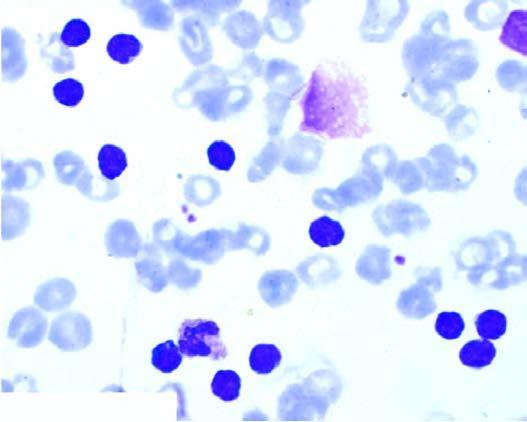how many degenerated forms appearing as bare smudged nuclei?
Answer the question using a single word or phrase. Some 